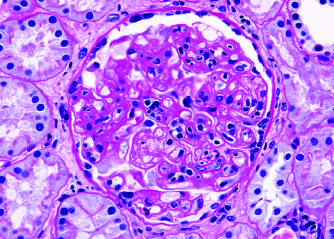what does the glomerulus show within the capillary loops glomerulitis, accumulation of mesangial matrix, and duplication of the capillary basement membrane?
Answer the question using a single word or phrase. Inflammatory cells 